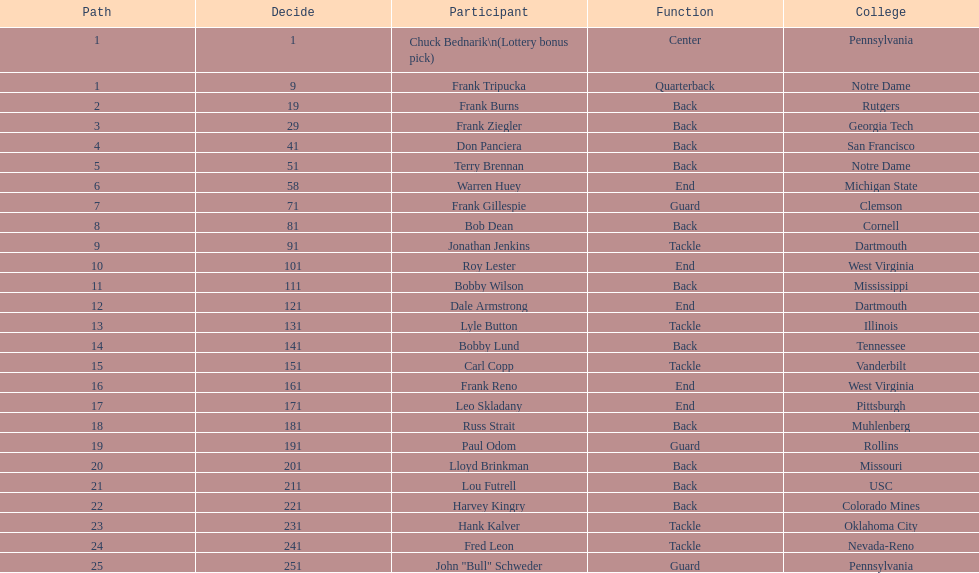Was chuck bednarik or frank tripucka the first draft pick? Chuck Bednarik. 